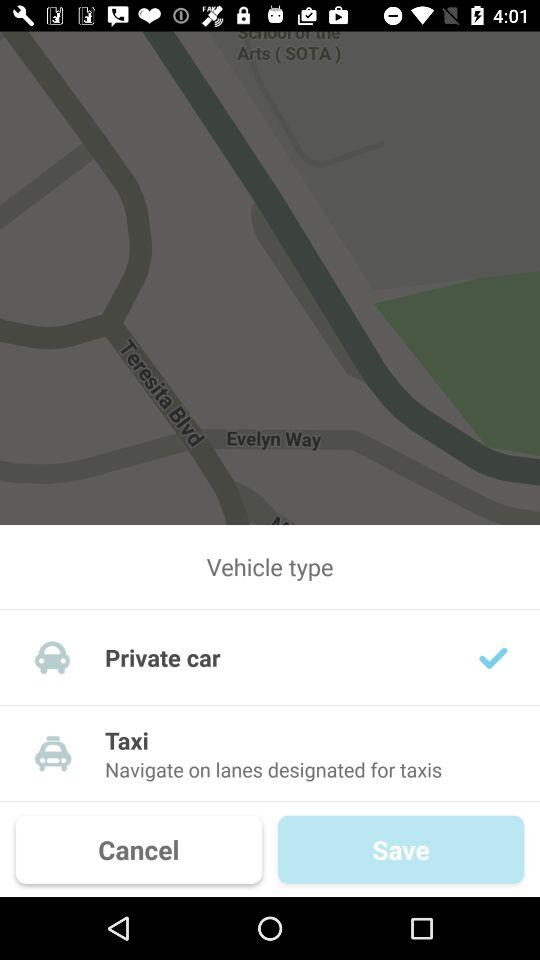What type of vehicle is available there? The available types of vehicles are "Private car" and "Taxi". 